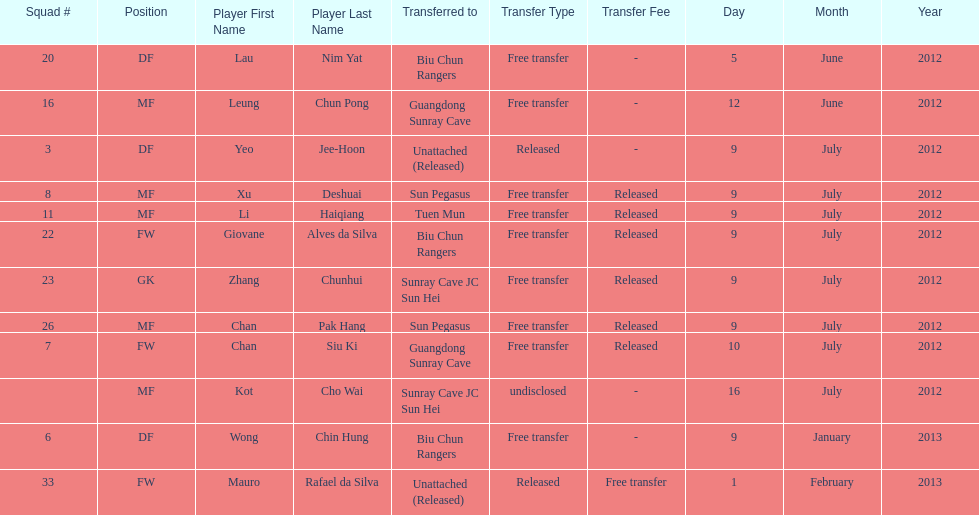Lau nim yat and giovane alves de silva where both transferred to which team? Biu Chun Rangers. 